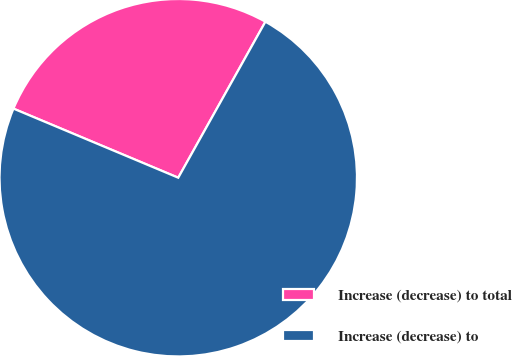Convert chart to OTSL. <chart><loc_0><loc_0><loc_500><loc_500><pie_chart><fcel>Increase (decrease) to total<fcel>Increase (decrease) to<nl><fcel>26.79%<fcel>73.21%<nl></chart> 